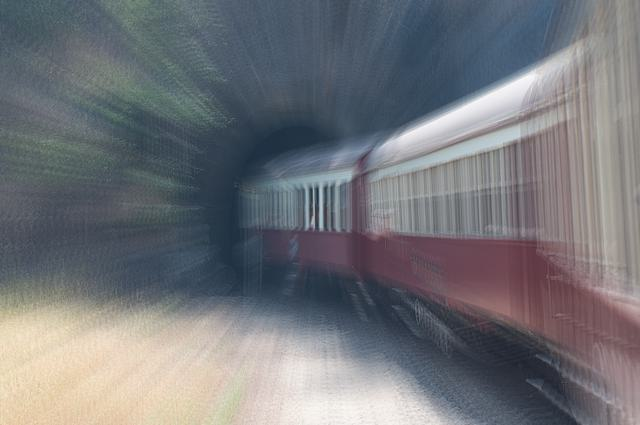What artistic techniques can you identify in this image? The image employs motion blur, a technique used to suggest speed and movement. By using a slow shutter speed, the photographer has captured the train in such a way that it appears to be swiftly moving through the environment, emphasizing the action within the frame. What emotions might this image be trying to convey? The use of motion blur can evoke feelings of haste or urgency, illustrating the swift passage of time. There's a dynamic energy captured, possibly signifying progress or the relentless pace of life. Furthermore, the tunnel may symbolize transition or entering into a new phase or destination. 